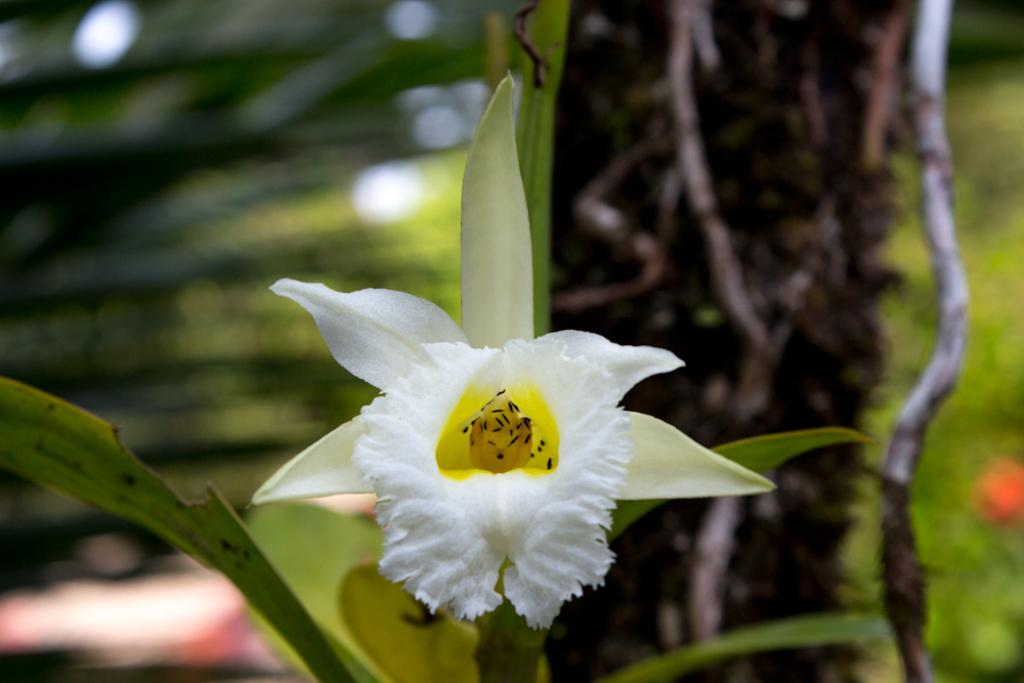What type of plant is visible in the image? There is a plant with a flower in the image. Can you describe the background of the image? The background of the image is blurred. What can be seen in the background of the image? Planets and objects are visible in the background of the image. What type of coal can be seen in the image? There is no coal present in the image. Can you hear any thunder in the image? There is no sound in the image, so it is impossible to determine if there is thunder. 